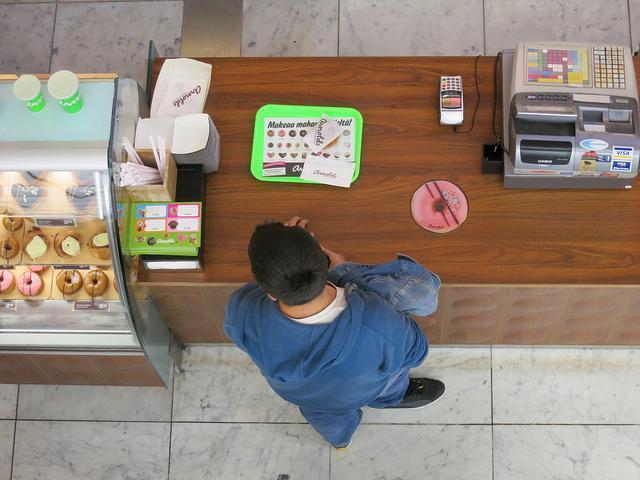How many cups are on top of the display case?
Give a very brief answer. 2. How many zebras are visible?
Give a very brief answer. 0. 